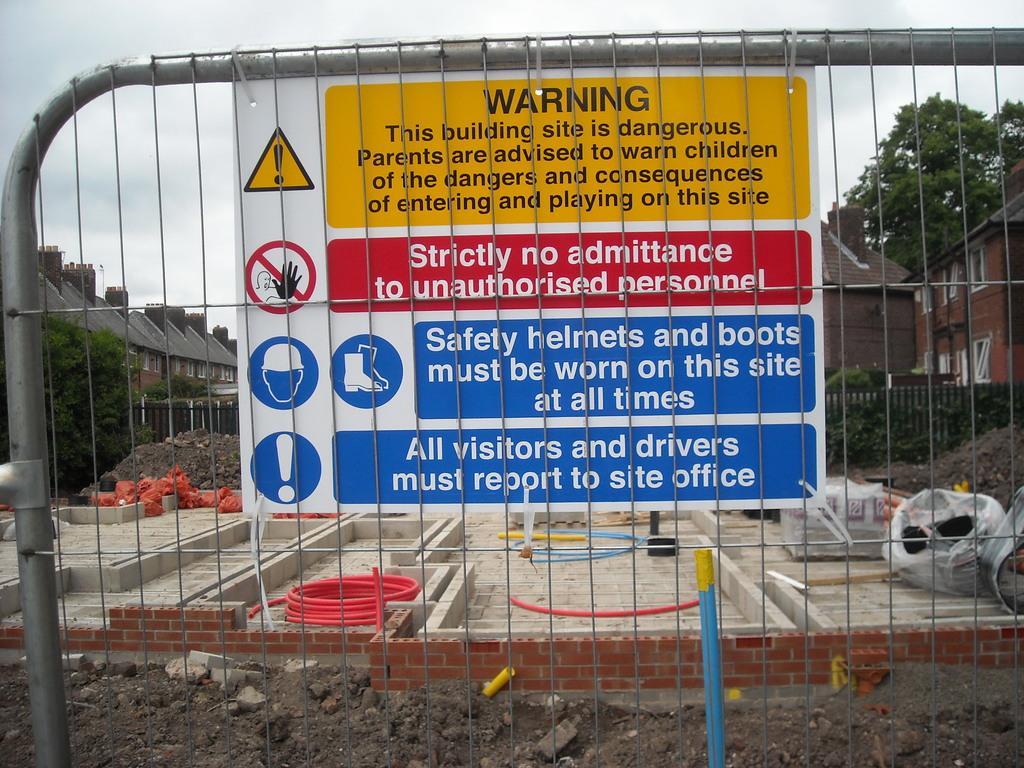What is written on the warning sign with the red background?
Provide a succinct answer. Unanswerable. What word is on the top of the sign?
Your response must be concise. Warning. 